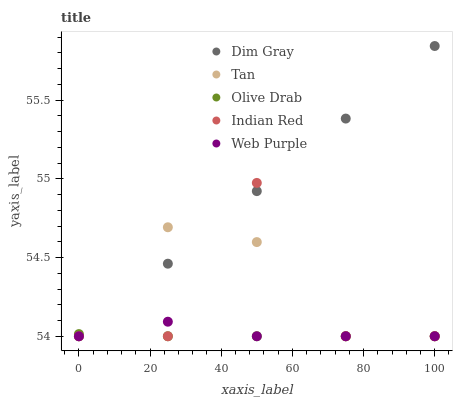Does Olive Drab have the minimum area under the curve?
Answer yes or no. Yes. Does Dim Gray have the maximum area under the curve?
Answer yes or no. Yes. Does Tan have the minimum area under the curve?
Answer yes or no. No. Does Tan have the maximum area under the curve?
Answer yes or no. No. Is Dim Gray the smoothest?
Answer yes or no. Yes. Is Indian Red the roughest?
Answer yes or no. Yes. Is Tan the smoothest?
Answer yes or no. No. Is Tan the roughest?
Answer yes or no. No. Does Web Purple have the lowest value?
Answer yes or no. Yes. Does Dim Gray have the highest value?
Answer yes or no. Yes. Does Tan have the highest value?
Answer yes or no. No. Does Olive Drab intersect Web Purple?
Answer yes or no. Yes. Is Olive Drab less than Web Purple?
Answer yes or no. No. Is Olive Drab greater than Web Purple?
Answer yes or no. No. 